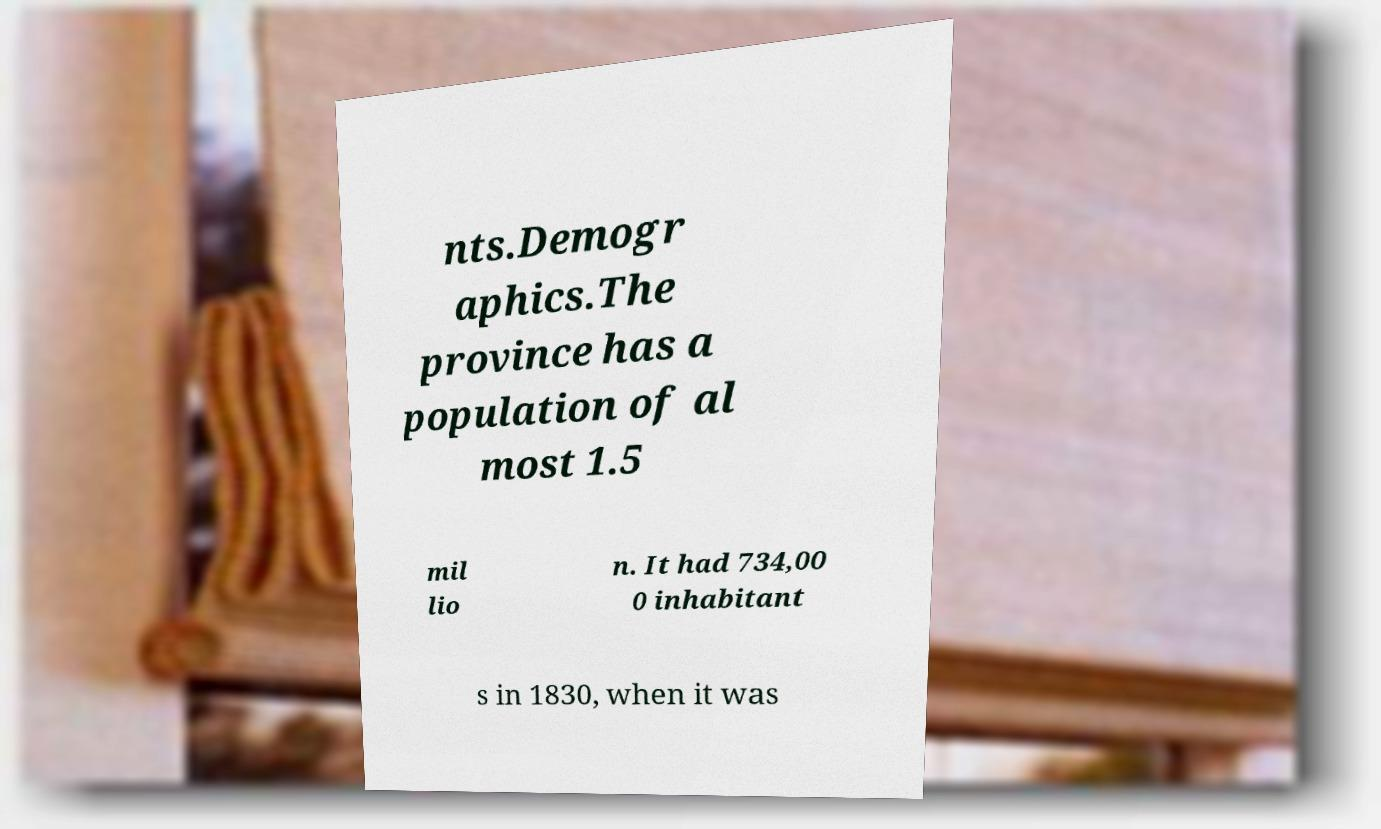Can you accurately transcribe the text from the provided image for me? nts.Demogr aphics.The province has a population of al most 1.5 mil lio n. It had 734,00 0 inhabitant s in 1830, when it was 